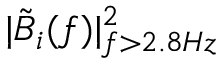<formula> <loc_0><loc_0><loc_500><loc_500>| \tilde { B } _ { i } ( f ) | _ { f > 2 . 8 H z } ^ { 2 }</formula> 